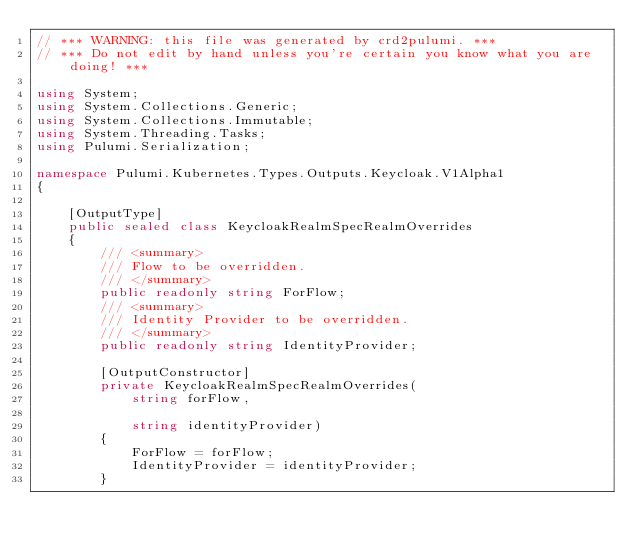Convert code to text. <code><loc_0><loc_0><loc_500><loc_500><_C#_>// *** WARNING: this file was generated by crd2pulumi. ***
// *** Do not edit by hand unless you're certain you know what you are doing! ***

using System;
using System.Collections.Generic;
using System.Collections.Immutable;
using System.Threading.Tasks;
using Pulumi.Serialization;

namespace Pulumi.Kubernetes.Types.Outputs.Keycloak.V1Alpha1
{

    [OutputType]
    public sealed class KeycloakRealmSpecRealmOverrides
    {
        /// <summary>
        /// Flow to be overridden.
        /// </summary>
        public readonly string ForFlow;
        /// <summary>
        /// Identity Provider to be overridden.
        /// </summary>
        public readonly string IdentityProvider;

        [OutputConstructor]
        private KeycloakRealmSpecRealmOverrides(
            string forFlow,

            string identityProvider)
        {
            ForFlow = forFlow;
            IdentityProvider = identityProvider;
        }</code> 